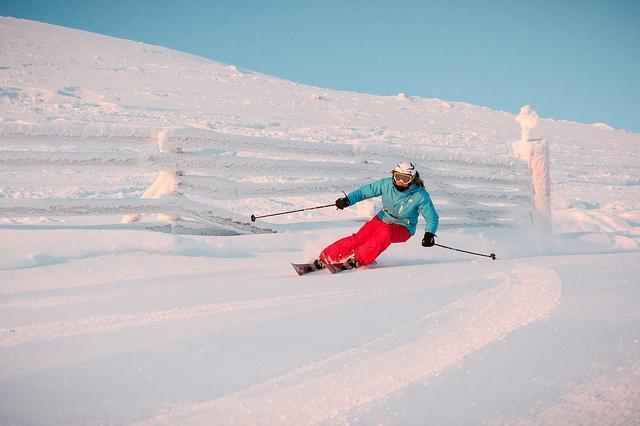How many poles are they using?
Give a very brief answer. 2. How many people are skiing?
Give a very brief answer. 1. How many people are shown?
Give a very brief answer. 1. 